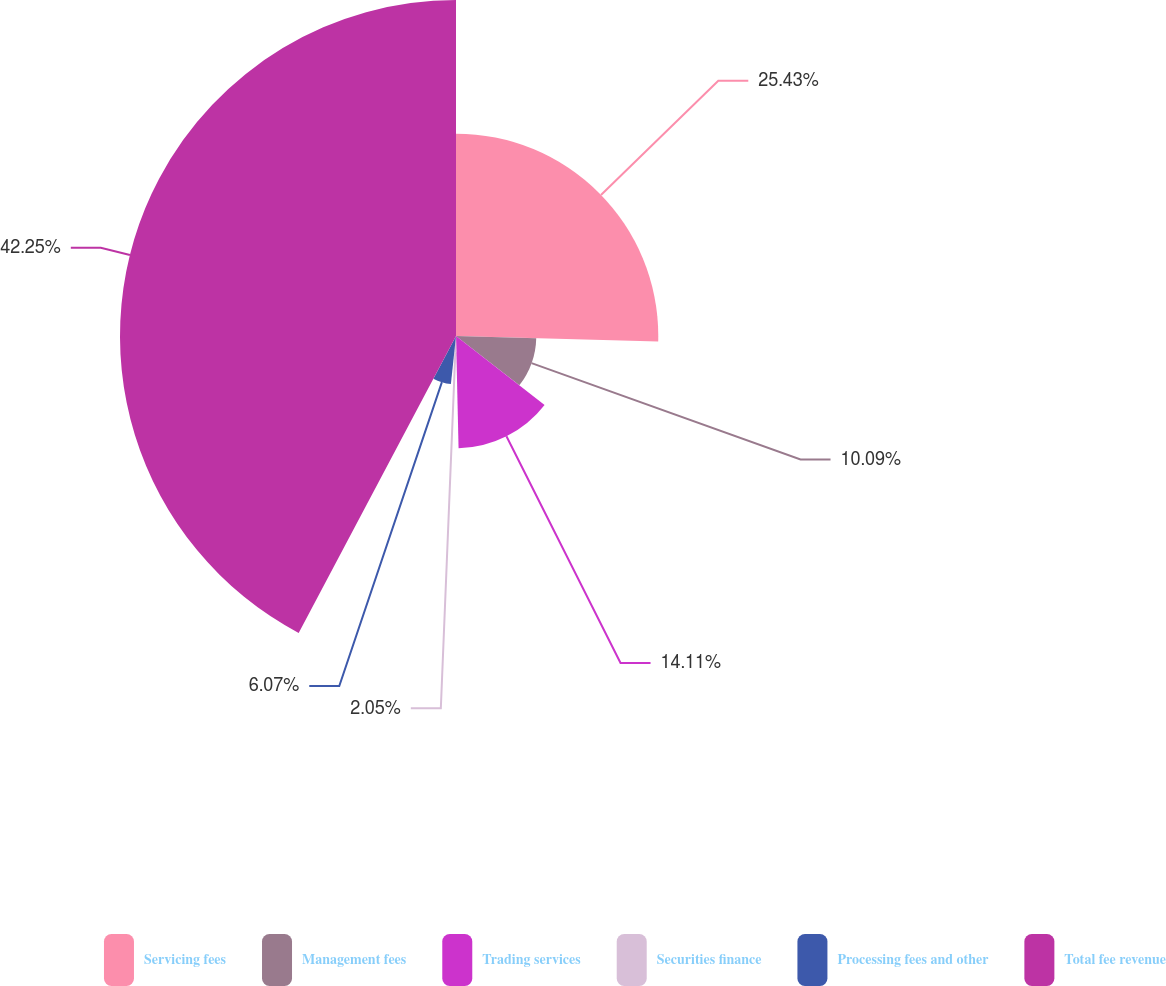Convert chart to OTSL. <chart><loc_0><loc_0><loc_500><loc_500><pie_chart><fcel>Servicing fees<fcel>Management fees<fcel>Trading services<fcel>Securities finance<fcel>Processing fees and other<fcel>Total fee revenue<nl><fcel>25.43%<fcel>10.09%<fcel>14.11%<fcel>2.05%<fcel>6.07%<fcel>42.24%<nl></chart> 